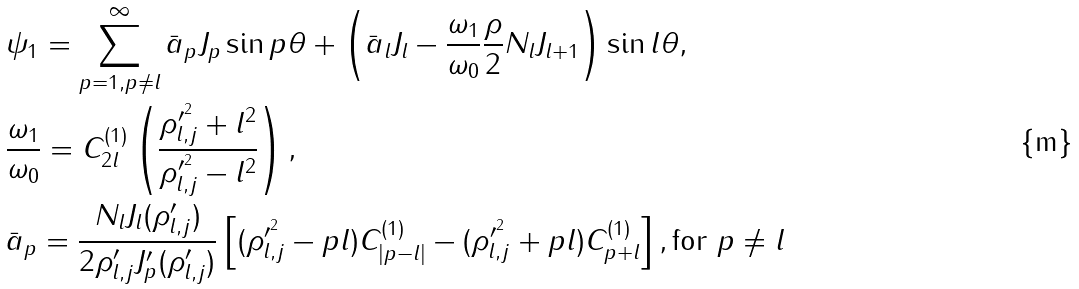<formula> <loc_0><loc_0><loc_500><loc_500>& \psi _ { 1 } = \sum _ { p = 1 , p \neq l } ^ { \infty } \bar { a } _ { p } J _ { p } \sin p \theta + \left ( \bar { a } _ { l } J _ { l } - \frac { \omega _ { 1 } } { \omega _ { 0 } } \frac { \rho } { 2 } N _ { l } J _ { l + 1 } \right ) \sin l \theta , \\ & \frac { \omega _ { 1 } } { \omega _ { 0 } } = C _ { 2 l } ^ { ( 1 ) } \left ( \frac { \rho ^ { \prime ^ { 2 } } _ { l , j } + l ^ { 2 } } { \rho ^ { \prime ^ { 2 } } _ { l , j } - l ^ { 2 } } \right ) , \\ & \bar { a } _ { p } = \frac { N _ { l } J _ { l } ( \rho ^ { \prime } _ { l , j } ) } { 2 \rho ^ { \prime } _ { l , j } J _ { p } ^ { \prime } ( \rho ^ { \prime } _ { l , j } ) } \left [ ( \rho ^ { \prime ^ { 2 } } _ { l , j } - p l ) C _ { | p - l | } ^ { ( 1 ) } - ( \rho ^ { \prime ^ { 2 } } _ { l , j } + p l ) C _ { p + l } ^ { ( 1 ) } \right ] , \text {for $p\neq l$}</formula> 